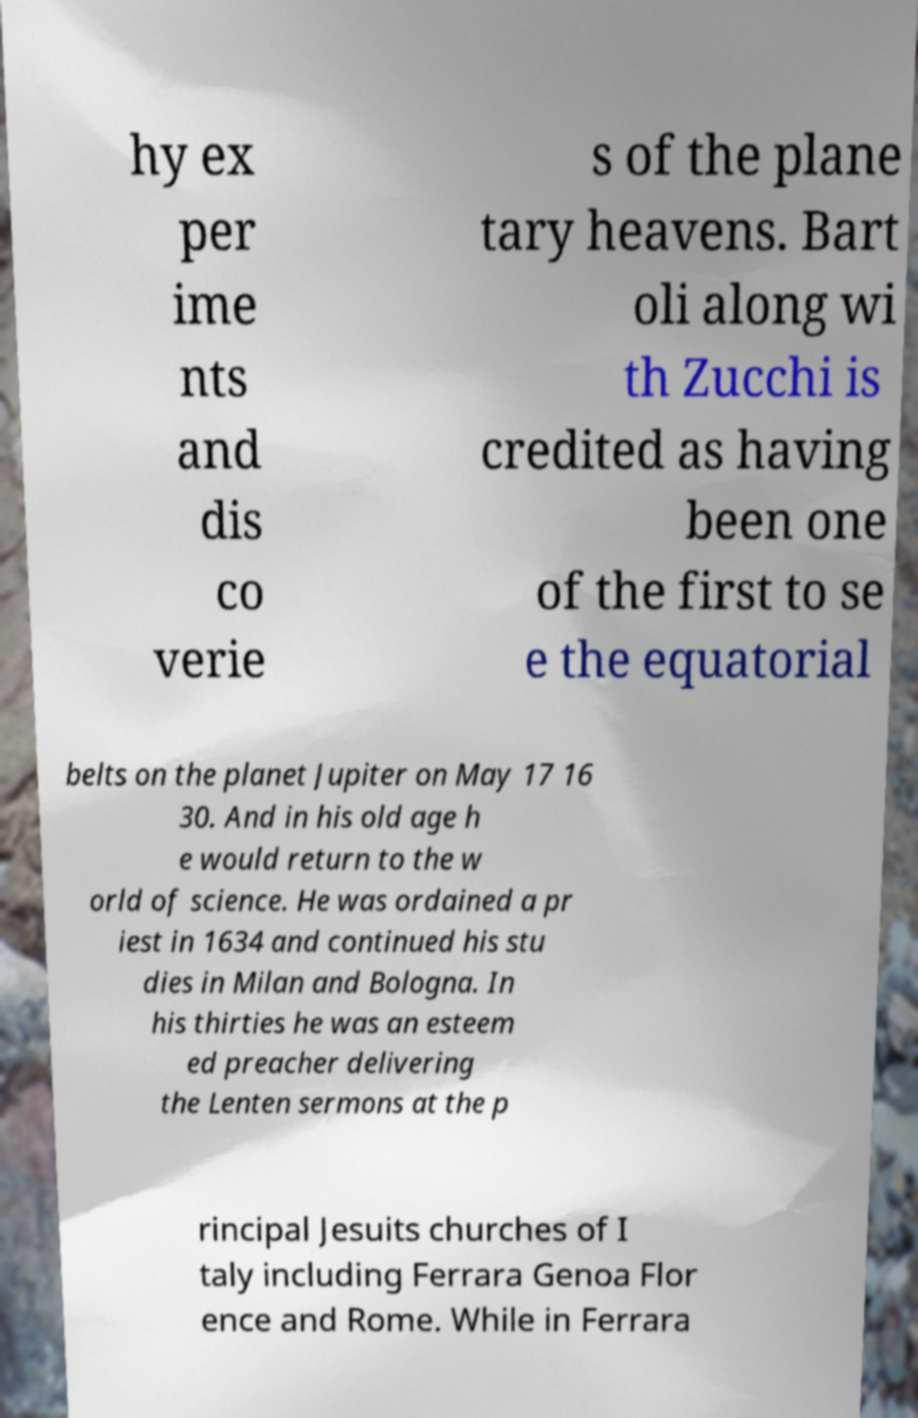Could you extract and type out the text from this image? hy ex per ime nts and dis co verie s of the plane tary heavens. Bart oli along wi th Zucchi is credited as having been one of the first to se e the equatorial belts on the planet Jupiter on May 17 16 30. And in his old age h e would return to the w orld of science. He was ordained a pr iest in 1634 and continued his stu dies in Milan and Bologna. In his thirties he was an esteem ed preacher delivering the Lenten sermons at the p rincipal Jesuits churches of I taly including Ferrara Genoa Flor ence and Rome. While in Ferrara 